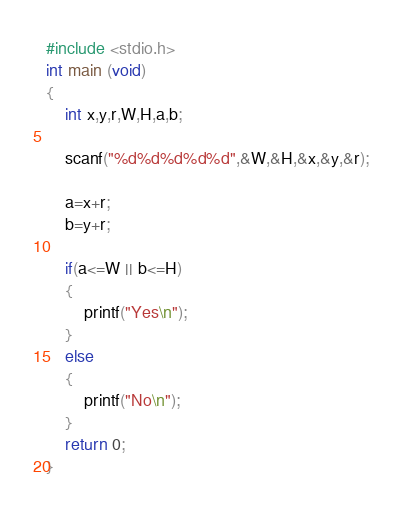<code> <loc_0><loc_0><loc_500><loc_500><_C_>#include <stdio.h>
int main (void)
{
	int x,y,r,W,H,a,b;
	
	scanf("%d%d%d%d%d",&W,&H,&x,&y,&r);
	
	a=x+r;
	b=y+r;
	
	if(a<=W || b<=H)
	{
		printf("Yes\n");
	}
	else
	{
		printf("No\n");
	}
	return 0;
}</code> 